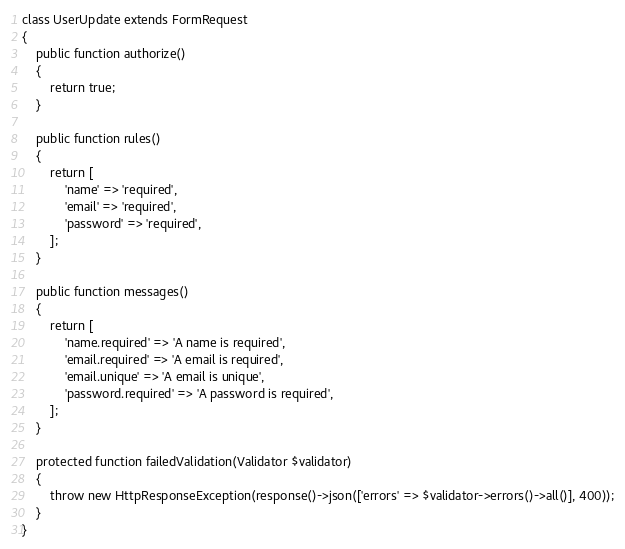<code> <loc_0><loc_0><loc_500><loc_500><_PHP_>
class UserUpdate extends FormRequest
{
    public function authorize()
    {
        return true;
    }

    public function rules()
    {
        return [
            'name' => 'required',
            'email' => 'required',
            'password' => 'required',
        ];
    }

    public function messages()
    {
        return [
            'name.required' => 'A name is required',
            'email.required' => 'A email is required',
            'email.unique' => 'A email is unique',
            'password.required' => 'A password is required',
        ];
    }

    protected function failedValidation(Validator $validator)
    {
        throw new HttpResponseException(response()->json(['errors' => $validator->errors()->all()], 400));
    }
}
</code> 